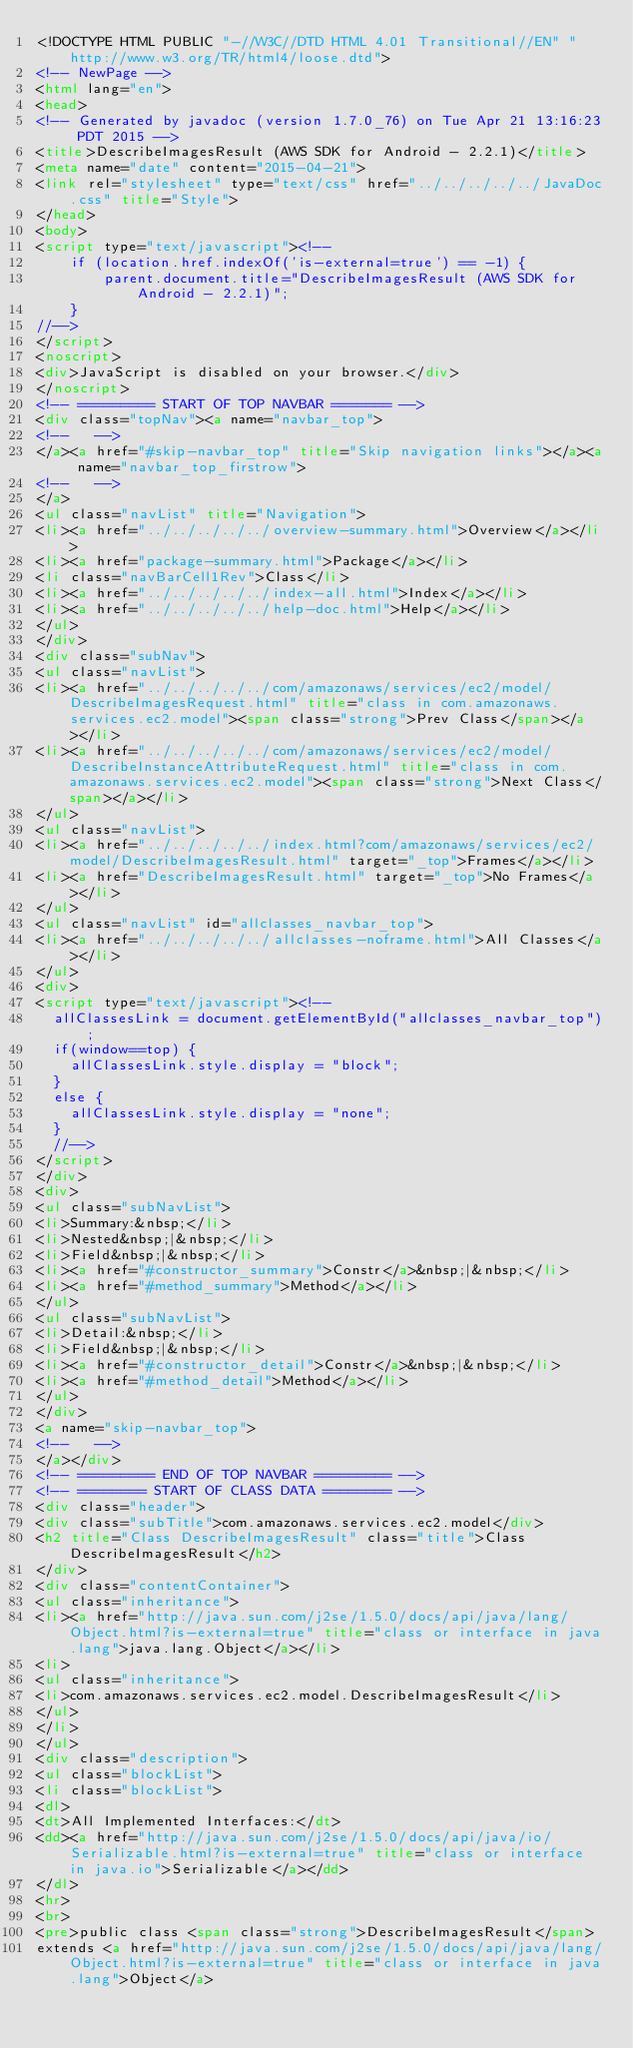Convert code to text. <code><loc_0><loc_0><loc_500><loc_500><_HTML_><!DOCTYPE HTML PUBLIC "-//W3C//DTD HTML 4.01 Transitional//EN" "http://www.w3.org/TR/html4/loose.dtd">
<!-- NewPage -->
<html lang="en">
<head>
<!-- Generated by javadoc (version 1.7.0_76) on Tue Apr 21 13:16:23 PDT 2015 -->
<title>DescribeImagesResult (AWS SDK for Android - 2.2.1)</title>
<meta name="date" content="2015-04-21">
<link rel="stylesheet" type="text/css" href="../../../../../JavaDoc.css" title="Style">
</head>
<body>
<script type="text/javascript"><!--
    if (location.href.indexOf('is-external=true') == -1) {
        parent.document.title="DescribeImagesResult (AWS SDK for Android - 2.2.1)";
    }
//-->
</script>
<noscript>
<div>JavaScript is disabled on your browser.</div>
</noscript>
<!-- ========= START OF TOP NAVBAR ======= -->
<div class="topNav"><a name="navbar_top">
<!--   -->
</a><a href="#skip-navbar_top" title="Skip navigation links"></a><a name="navbar_top_firstrow">
<!--   -->
</a>
<ul class="navList" title="Navigation">
<li><a href="../../../../../overview-summary.html">Overview</a></li>
<li><a href="package-summary.html">Package</a></li>
<li class="navBarCell1Rev">Class</li>
<li><a href="../../../../../index-all.html">Index</a></li>
<li><a href="../../../../../help-doc.html">Help</a></li>
</ul>
</div>
<div class="subNav">
<ul class="navList">
<li><a href="../../../../../com/amazonaws/services/ec2/model/DescribeImagesRequest.html" title="class in com.amazonaws.services.ec2.model"><span class="strong">Prev Class</span></a></li>
<li><a href="../../../../../com/amazonaws/services/ec2/model/DescribeInstanceAttributeRequest.html" title="class in com.amazonaws.services.ec2.model"><span class="strong">Next Class</span></a></li>
</ul>
<ul class="navList">
<li><a href="../../../../../index.html?com/amazonaws/services/ec2/model/DescribeImagesResult.html" target="_top">Frames</a></li>
<li><a href="DescribeImagesResult.html" target="_top">No Frames</a></li>
</ul>
<ul class="navList" id="allclasses_navbar_top">
<li><a href="../../../../../allclasses-noframe.html">All Classes</a></li>
</ul>
<div>
<script type="text/javascript"><!--
  allClassesLink = document.getElementById("allclasses_navbar_top");
  if(window==top) {
    allClassesLink.style.display = "block";
  }
  else {
    allClassesLink.style.display = "none";
  }
  //-->
</script>
</div>
<div>
<ul class="subNavList">
<li>Summary:&nbsp;</li>
<li>Nested&nbsp;|&nbsp;</li>
<li>Field&nbsp;|&nbsp;</li>
<li><a href="#constructor_summary">Constr</a>&nbsp;|&nbsp;</li>
<li><a href="#method_summary">Method</a></li>
</ul>
<ul class="subNavList">
<li>Detail:&nbsp;</li>
<li>Field&nbsp;|&nbsp;</li>
<li><a href="#constructor_detail">Constr</a>&nbsp;|&nbsp;</li>
<li><a href="#method_detail">Method</a></li>
</ul>
</div>
<a name="skip-navbar_top">
<!--   -->
</a></div>
<!-- ========= END OF TOP NAVBAR ========= -->
<!-- ======== START OF CLASS DATA ======== -->
<div class="header">
<div class="subTitle">com.amazonaws.services.ec2.model</div>
<h2 title="Class DescribeImagesResult" class="title">Class DescribeImagesResult</h2>
</div>
<div class="contentContainer">
<ul class="inheritance">
<li><a href="http://java.sun.com/j2se/1.5.0/docs/api/java/lang/Object.html?is-external=true" title="class or interface in java.lang">java.lang.Object</a></li>
<li>
<ul class="inheritance">
<li>com.amazonaws.services.ec2.model.DescribeImagesResult</li>
</ul>
</li>
</ul>
<div class="description">
<ul class="blockList">
<li class="blockList">
<dl>
<dt>All Implemented Interfaces:</dt>
<dd><a href="http://java.sun.com/j2se/1.5.0/docs/api/java/io/Serializable.html?is-external=true" title="class or interface in java.io">Serializable</a></dd>
</dl>
<hr>
<br>
<pre>public class <span class="strong">DescribeImagesResult</span>
extends <a href="http://java.sun.com/j2se/1.5.0/docs/api/java/lang/Object.html?is-external=true" title="class or interface in java.lang">Object</a></code> 